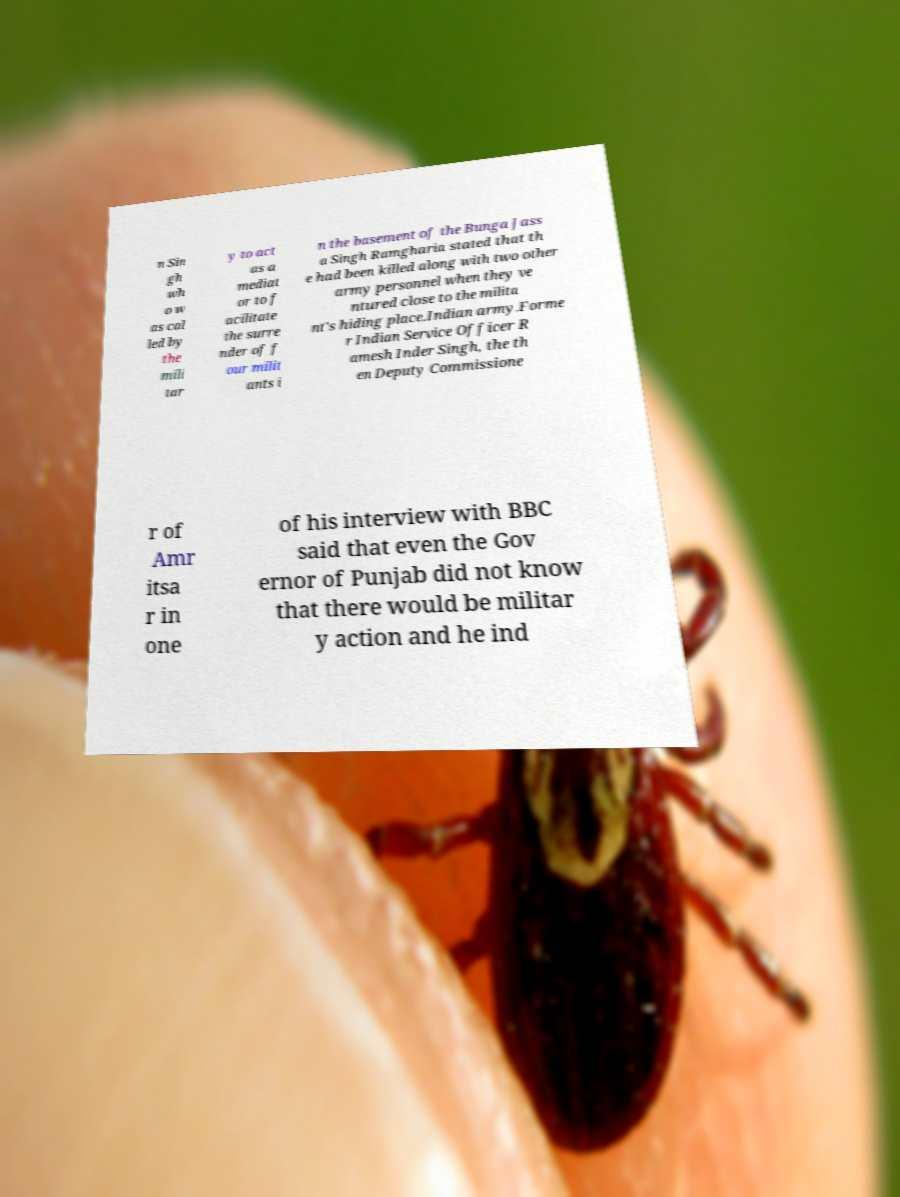Please read and relay the text visible in this image. What does it say? n Sin gh wh o w as cal led by the mili tar y to act as a mediat or to f acilitate the surre nder of f our milit ants i n the basement of the Bunga Jass a Singh Ramgharia stated that th e had been killed along with two other army personnel when they ve ntured close to the milita nt's hiding place.Indian army.Forme r Indian Service Officer R amesh Inder Singh, the th en Deputy Commissione r of Amr itsa r in one of his interview with BBC said that even the Gov ernor of Punjab did not know that there would be militar y action and he ind 